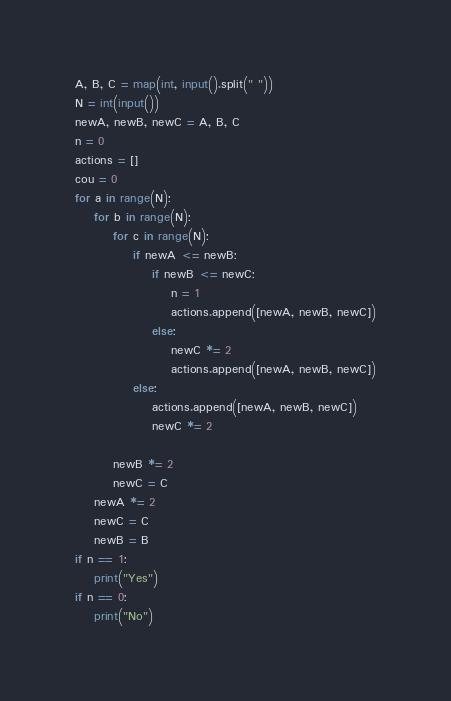Convert code to text. <code><loc_0><loc_0><loc_500><loc_500><_Python_>A, B, C = map(int, input().split(" "))
N = int(input())
newA, newB, newC = A, B, C
n = 0
actions = []
cou = 0
for a in range(N):
    for b in range(N):
        for c in range(N):
            if newA <= newB:
                if newB <= newC:
                    n = 1
                    actions.append([newA, newB, newC])
                else:
                    newC *= 2
                    actions.append([newA, newB, newC])
            else:
                actions.append([newA, newB, newC])
                newC *= 2
                
        newB *= 2
        newC = C
    newA *= 2
    newC = C
    newB = B
if n == 1:
    print("Yes")
if n == 0:
    print("No")</code> 